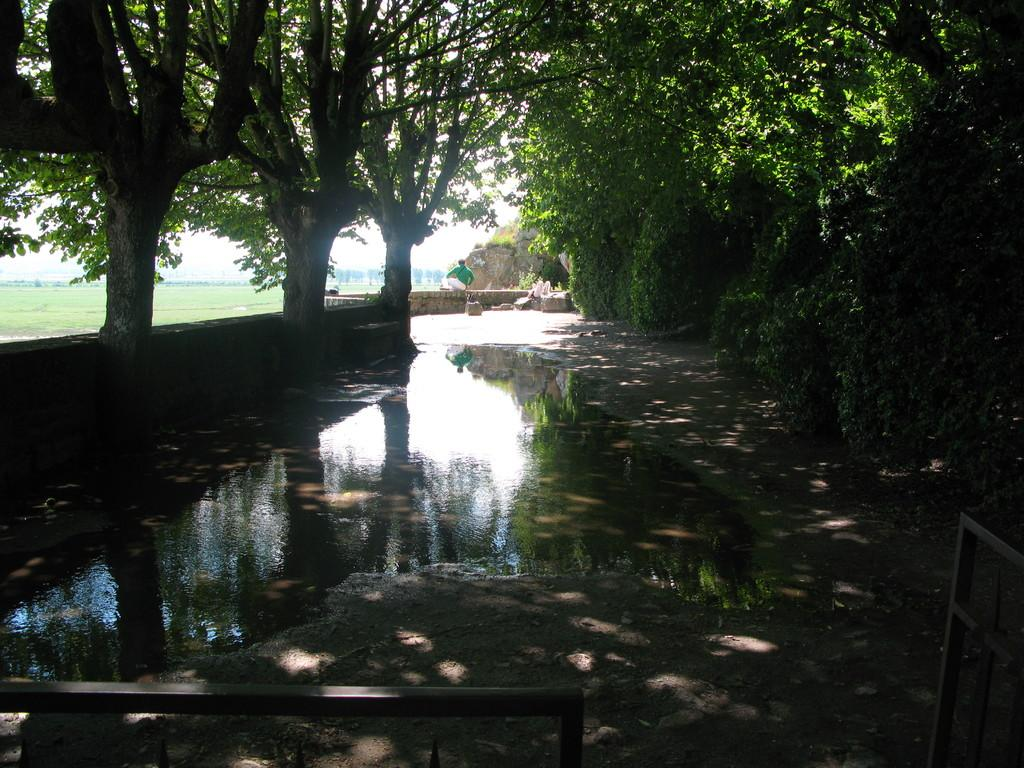What is in the foreground of the image? There is water in the foreground of the image. What can be seen at the bottom side of the image? There appears to be railing at the bottom side of the image What type of vegetation is in the background of the image? There are trees in the background of the image. What type of terrain is in the background of the image? There is grassland in the background of the image. What type of material is present in the background of the image? Stones are present in the background of the image. Can you describe the man in the background of the image? There is a man in the background of the image. What is visible in the background of the image? The sky is visible in the background of the image. Reasoning: We continue the conversation by expanding the focus to the background of the image, including the trees, grassland, stones, man, and sky. Each question is designed to elicit a specific detail about the image that is known from the provided facts. Absurd Question/Answer: How far away is the window from the man in the image? There is no window present in the image. What is the man's wealth based on the image? The image does not provide any information about the man's wealth. 